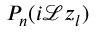<formula> <loc_0><loc_0><loc_500><loc_500>P _ { n } ( i \mathcal { L } z _ { l } )</formula> 